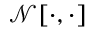Convert formula to latex. <formula><loc_0><loc_0><loc_500><loc_500>\mathcal { N } [ \cdot , \cdot ]</formula> 